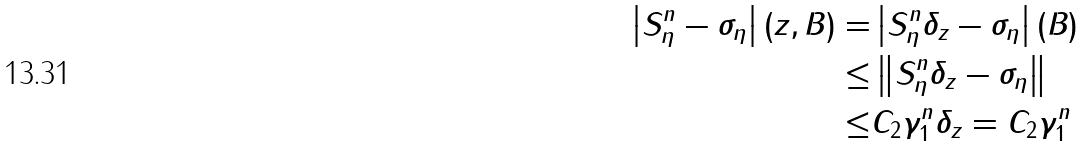Convert formula to latex. <formula><loc_0><loc_0><loc_500><loc_500>\left | S _ { \eta } ^ { n } - \sigma _ { \eta } \right | ( z , B ) = & \left | S _ { \eta } ^ { n } \delta _ { z } - \sigma _ { \eta } \right | ( B ) \\ \leq & \left \| S _ { \eta } ^ { n } \delta _ { z } - \sigma _ { \eta } \right \| \\ \leq & C _ { 2 } \gamma _ { 1 } ^ { n } \| \delta _ { z } \| = C _ { 2 } \gamma _ { 1 } ^ { n }</formula> 